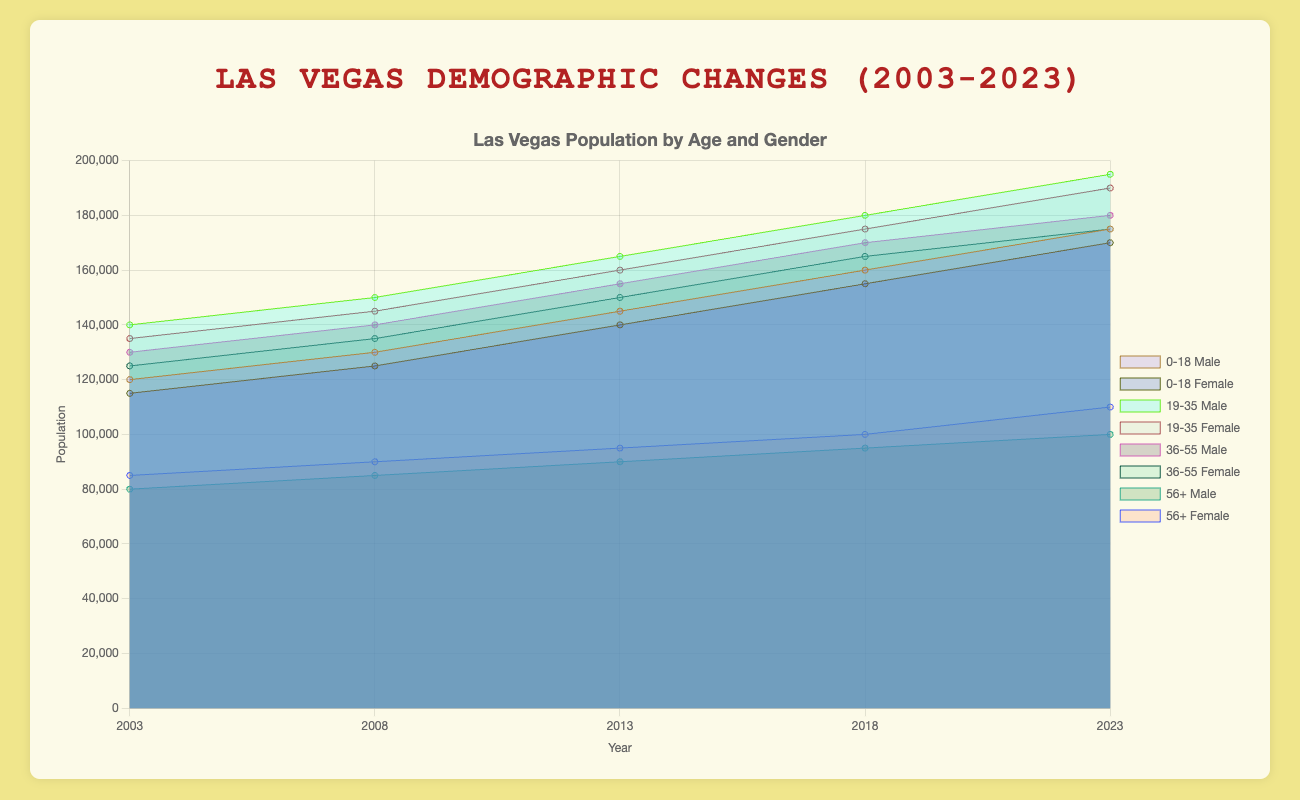Which age group showed the largest increase in both male and female populations from 2003 to 2023? To find the age group with the largest increase, subtract the 2003 population from the 2023 population for both males and females in each age group and sum the results. For age 0-18, the increase is (175000-120000) + (170000-115000) = 110000. For age 19-35, it is (195000-140000) + (190000-135000) = 110000. For age 36-55, it is (180000-130000) + (175000-125000) = 100000. For age 56+, it is (100000-80000) + (110000-85000) = 40000.
Answer: 0-18 and 19-35 What is the total population of 19-35 aged females in 2018? Look for the '19-35' age group and the female population in 2018. The data for females aged 19-35 in 2018 is 175000.
Answer: 175000 Which ethnicity group had the least male population in 2003? Compare the 2003 male population across all ethnicity groups: White (250000), Hispanic (150000), Black (70000), Asian (50000), and Other (30000). 'Other' had the least population.
Answer: Other How did the total population of the Asian ethnicity (both males and females) change from 2003 to 2023? Calculate the total change by adding 2023 population (both genders) and subtracting the 2003 population (both genders). The total in 2023 is (80000 + 82000) = 162000 and in 2003 is (50000 + 52000) = 102000. Thus, the change is 162000 - 102000 = 60000.
Answer: 60000 Which age group showed the most balanced gender distribution in 2023? For each age group in 2023, look at the difference between male and female populations. For 0-18, the difference is 175000 - 170000 = 5000. For 19-35, it is 195000 - 190000 = 5000. For 36-55, it is 180000 - 175000 = 5000. For 56+, it is 100000 - 110000 = 10000. All groups show a difference of 5000 except for the 56+ group, which has a difference of 10000, indicating that the 0-18, 19-35 and 36-55 groups are equally balanced.
Answer: 0-18, 19-35, 36-55 